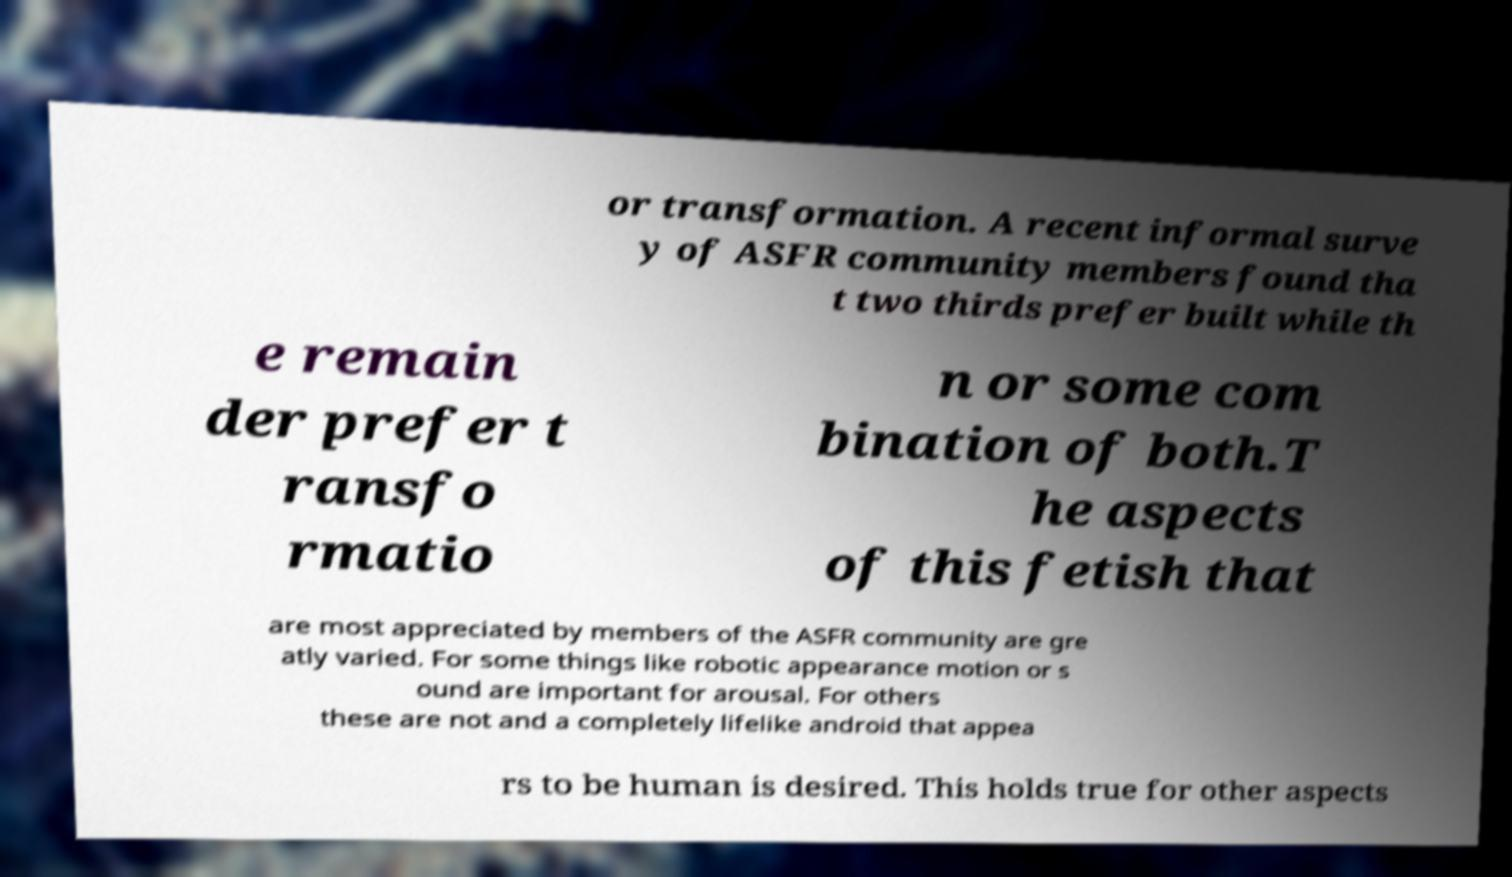Could you assist in decoding the text presented in this image and type it out clearly? or transformation. A recent informal surve y of ASFR community members found tha t two thirds prefer built while th e remain der prefer t ransfo rmatio n or some com bination of both.T he aspects of this fetish that are most appreciated by members of the ASFR community are gre atly varied. For some things like robotic appearance motion or s ound are important for arousal. For others these are not and a completely lifelike android that appea rs to be human is desired. This holds true for other aspects 